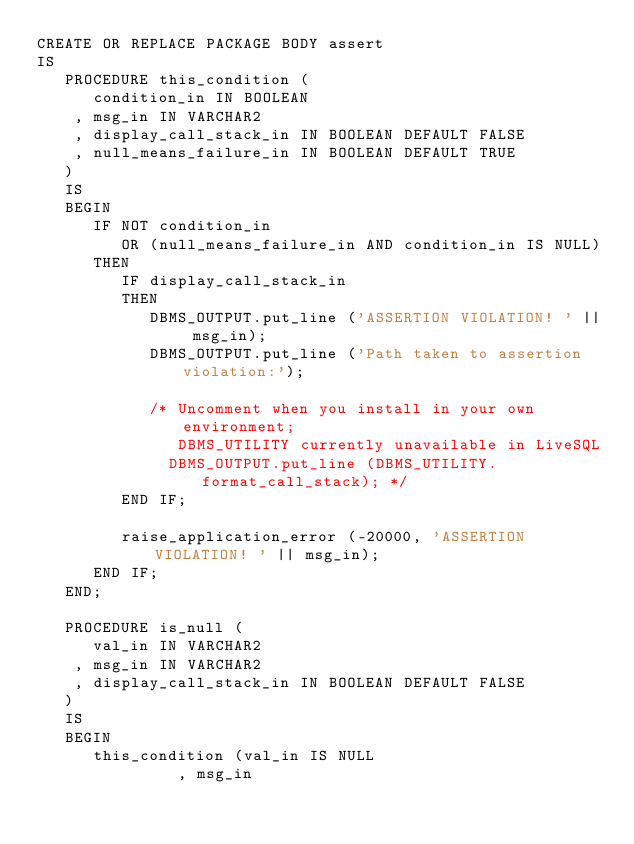Convert code to text. <code><loc_0><loc_0><loc_500><loc_500><_SQL_>CREATE OR REPLACE PACKAGE BODY assert  
IS  
   PROCEDURE this_condition (  
      condition_in IN BOOLEAN  
    , msg_in IN VARCHAR2  
    , display_call_stack_in IN BOOLEAN DEFAULT FALSE  
    , null_means_failure_in IN BOOLEAN DEFAULT TRUE  
   )  
   IS  
   BEGIN  
      IF NOT condition_in  
         OR (null_means_failure_in AND condition_in IS NULL)  
      THEN  
         IF display_call_stack_in  
         THEN  
            DBMS_OUTPUT.put_line ('ASSERTION VIOLATION! ' || msg_in);  
            DBMS_OUTPUT.put_line ('Path taken to assertion violation:');  
             
            /* Uncomment when you install in your own environment;  
               DBMS_UTILITY currently unavailable in LiveSQL  
              DBMS_OUTPUT.put_line (DBMS_UTILITY.format_call_stack); */ 
         END IF;  
  
         raise_application_error (-20000, 'ASSERTION VIOLATION! ' || msg_in);  
      END IF;  
   END;  
  
   PROCEDURE is_null (  
      val_in IN VARCHAR2  
    , msg_in IN VARCHAR2  
    , display_call_stack_in IN BOOLEAN DEFAULT FALSE  
   )  
   IS  
   BEGIN  
      this_condition (val_in IS NULL  
               , msg_in  </code> 